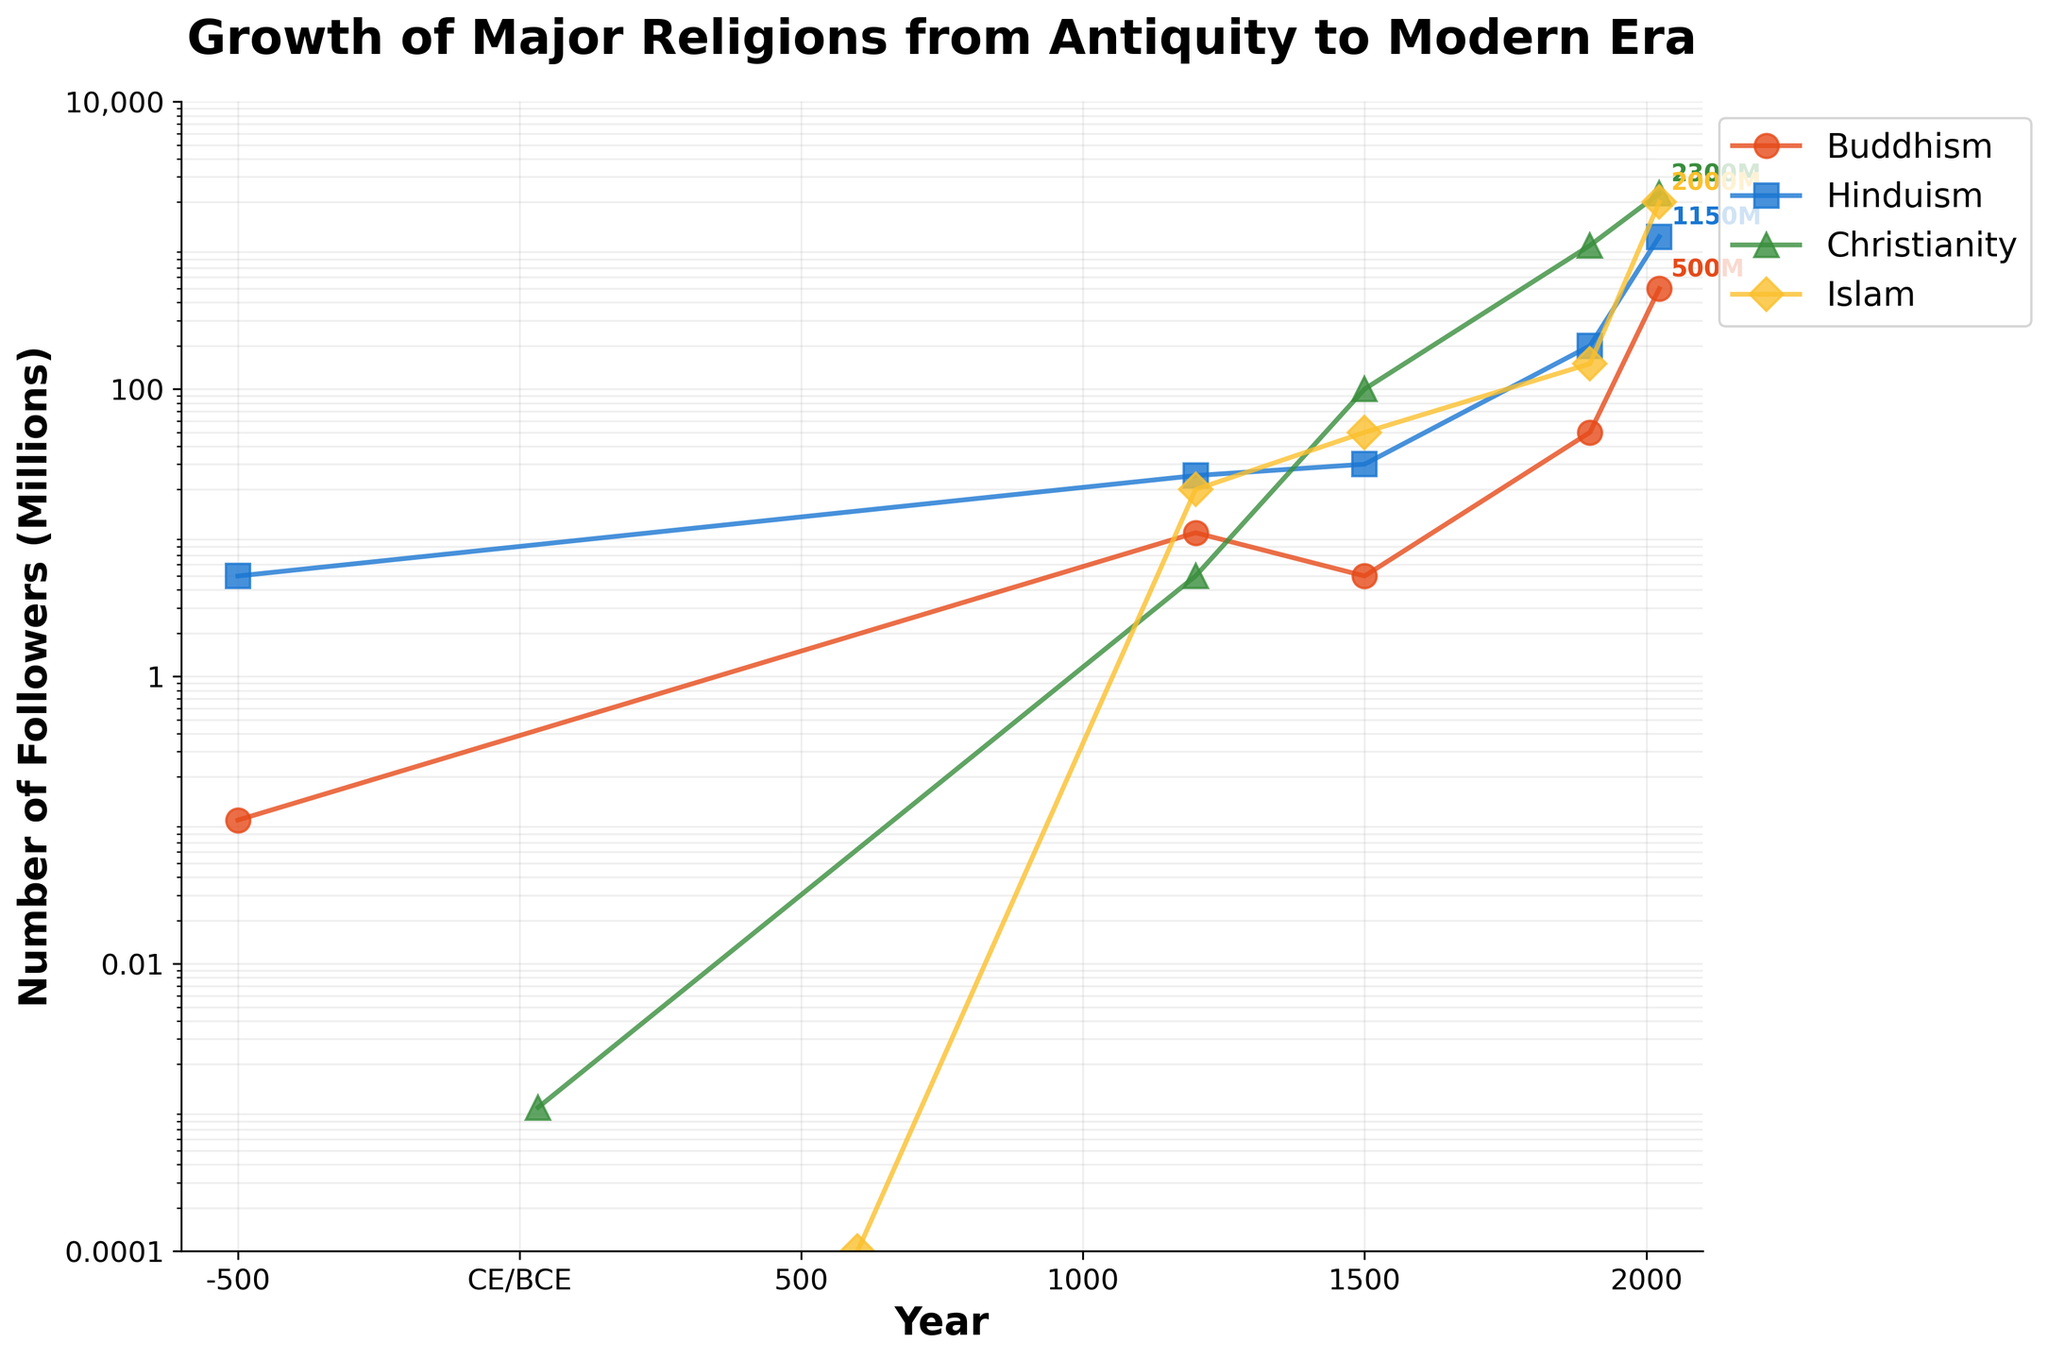What's the title of the plot? The title of the plot is displayed at the top and reads "Growth of Major Religions from Antiquity to Modern Era".
Answer: Growth of Major Religions from Antiquity to Modern Era How many religions are represented in the plot? There are four unique colors and labels in the legend, each representing a different religion. The religions shown are Buddhism, Hinduism, Christianity, and Islam.
Answer: Four Which religion had the most followers in 2023? By looking at the log scale data points at the year 2023, the line with the highest value is for Christianity, which intersects at 2300 million followers.
Answer: Christianity What is the range of the y-axis values? The y-axis is in a log scale and ranges from 0.0001 to 10,000 (0.0001M to 10,000M). This is indicated by the tick marks on the y-axis.
Answer: 0.0001 to 10,000 How do the numbers of followers of Buddhism compare between the years 1500 and 2023? At 1500, the number of followers of Buddhism is at 5 million, and at 2023, it is at 500 million. To compare: 500M - 5M = 495M, showing an increase of 495 million followers.
Answer: 495 million increase Which religion shows the fastest growth between 1500 and 1900? By comparing the slopes of the lines between 1500 and 1900, Islam shows the most significant increase in the number of followers, from 50 million to 150 million.
Answer: Islam What is the most significant change in the number of followers for Christianity throughout the entire plot? The most significant jump for Christianity comes between 1500 and 1900, where it goes from 100 million to 1000 million, an increase of 900 million followers.
Answer: 900 million During which century did Islam start to have a notable number of followers? Looking at the plot, Islam starts to show a noticeable increase in followers around the 1200 mark with 20 million followers.
Answer: 1200 What is the period with the least amount of growth for Hinduism? Hinduism grows steadily, but the smallest increase appears to be between 1500 (30 million) and 1900 (200 million). While this is still significant, it’s less steep compared to later periods.
Answer: Between 1500 and 1900 Which religion had the least number of followers at the year 33? The plot shows that Christianity had 0.001 million followers at year 33, which is the least compared to the other religions at that time.
Answer: Christianity 